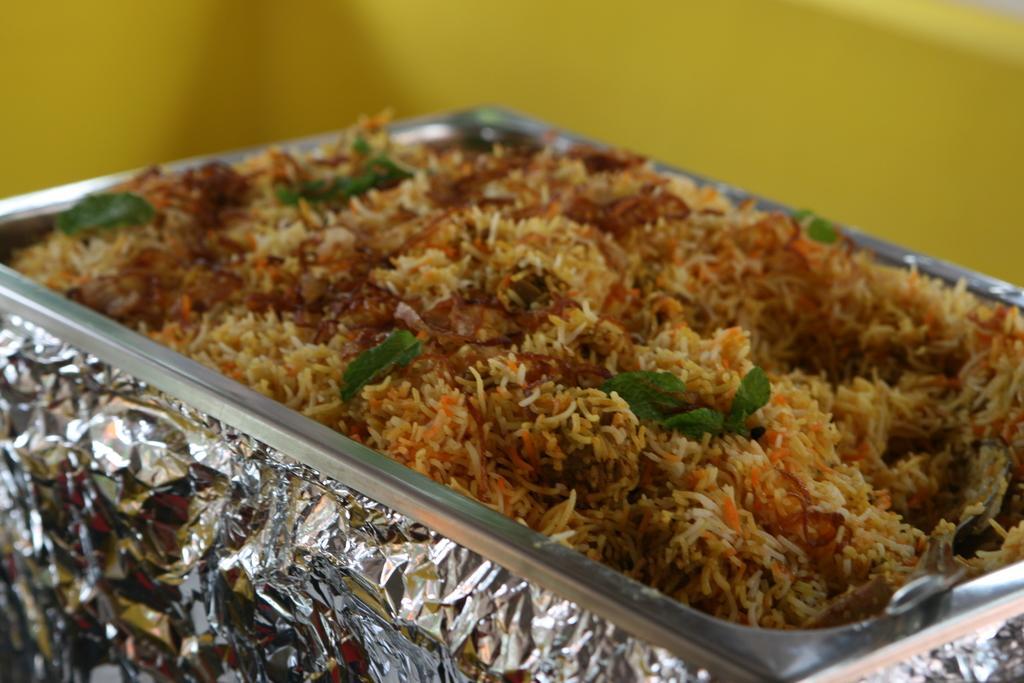Could you give a brief overview of what you see in this image? This image consists of a bowl in which there is rice. At the bottom, there is a silver foil. 